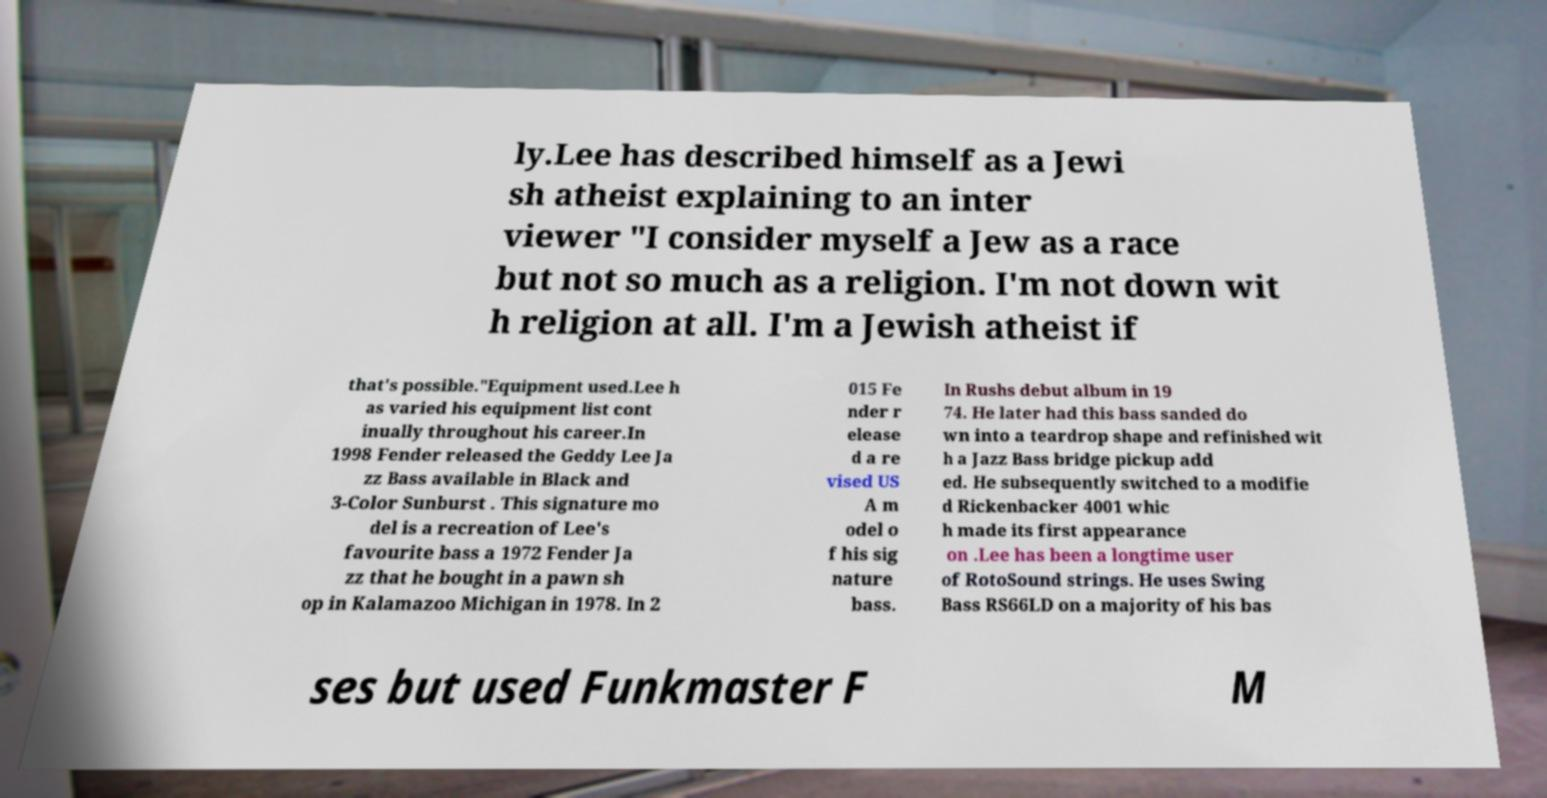Please identify and transcribe the text found in this image. ly.Lee has described himself as a Jewi sh atheist explaining to an inter viewer "I consider myself a Jew as a race but not so much as a religion. I'm not down wit h religion at all. I'm a Jewish atheist if that's possible."Equipment used.Lee h as varied his equipment list cont inually throughout his career.In 1998 Fender released the Geddy Lee Ja zz Bass available in Black and 3-Color Sunburst . This signature mo del is a recreation of Lee's favourite bass a 1972 Fender Ja zz that he bought in a pawn sh op in Kalamazoo Michigan in 1978. In 2 015 Fe nder r elease d a re vised US A m odel o f his sig nature bass. In Rushs debut album in 19 74. He later had this bass sanded do wn into a teardrop shape and refinished wit h a Jazz Bass bridge pickup add ed. He subsequently switched to a modifie d Rickenbacker 4001 whic h made its first appearance on .Lee has been a longtime user of RotoSound strings. He uses Swing Bass RS66LD on a majority of his bas ses but used Funkmaster F M 